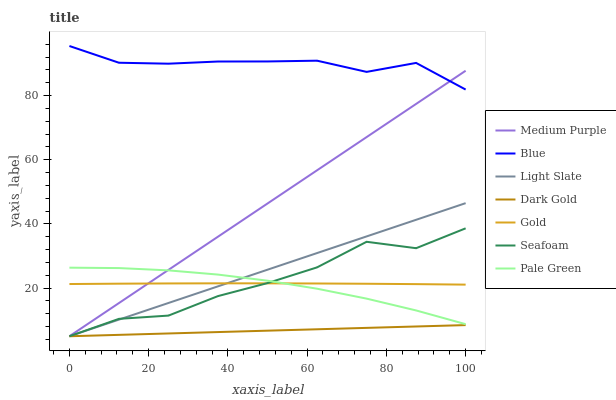Does Dark Gold have the minimum area under the curve?
Answer yes or no. Yes. Does Blue have the maximum area under the curve?
Answer yes or no. Yes. Does Gold have the minimum area under the curve?
Answer yes or no. No. Does Gold have the maximum area under the curve?
Answer yes or no. No. Is Dark Gold the smoothest?
Answer yes or no. Yes. Is Seafoam the roughest?
Answer yes or no. Yes. Is Gold the smoothest?
Answer yes or no. No. Is Gold the roughest?
Answer yes or no. No. Does Gold have the lowest value?
Answer yes or no. No. Does Gold have the highest value?
Answer yes or no. No. Is Dark Gold less than Pale Green?
Answer yes or no. Yes. Is Blue greater than Dark Gold?
Answer yes or no. Yes. Does Dark Gold intersect Pale Green?
Answer yes or no. No. 